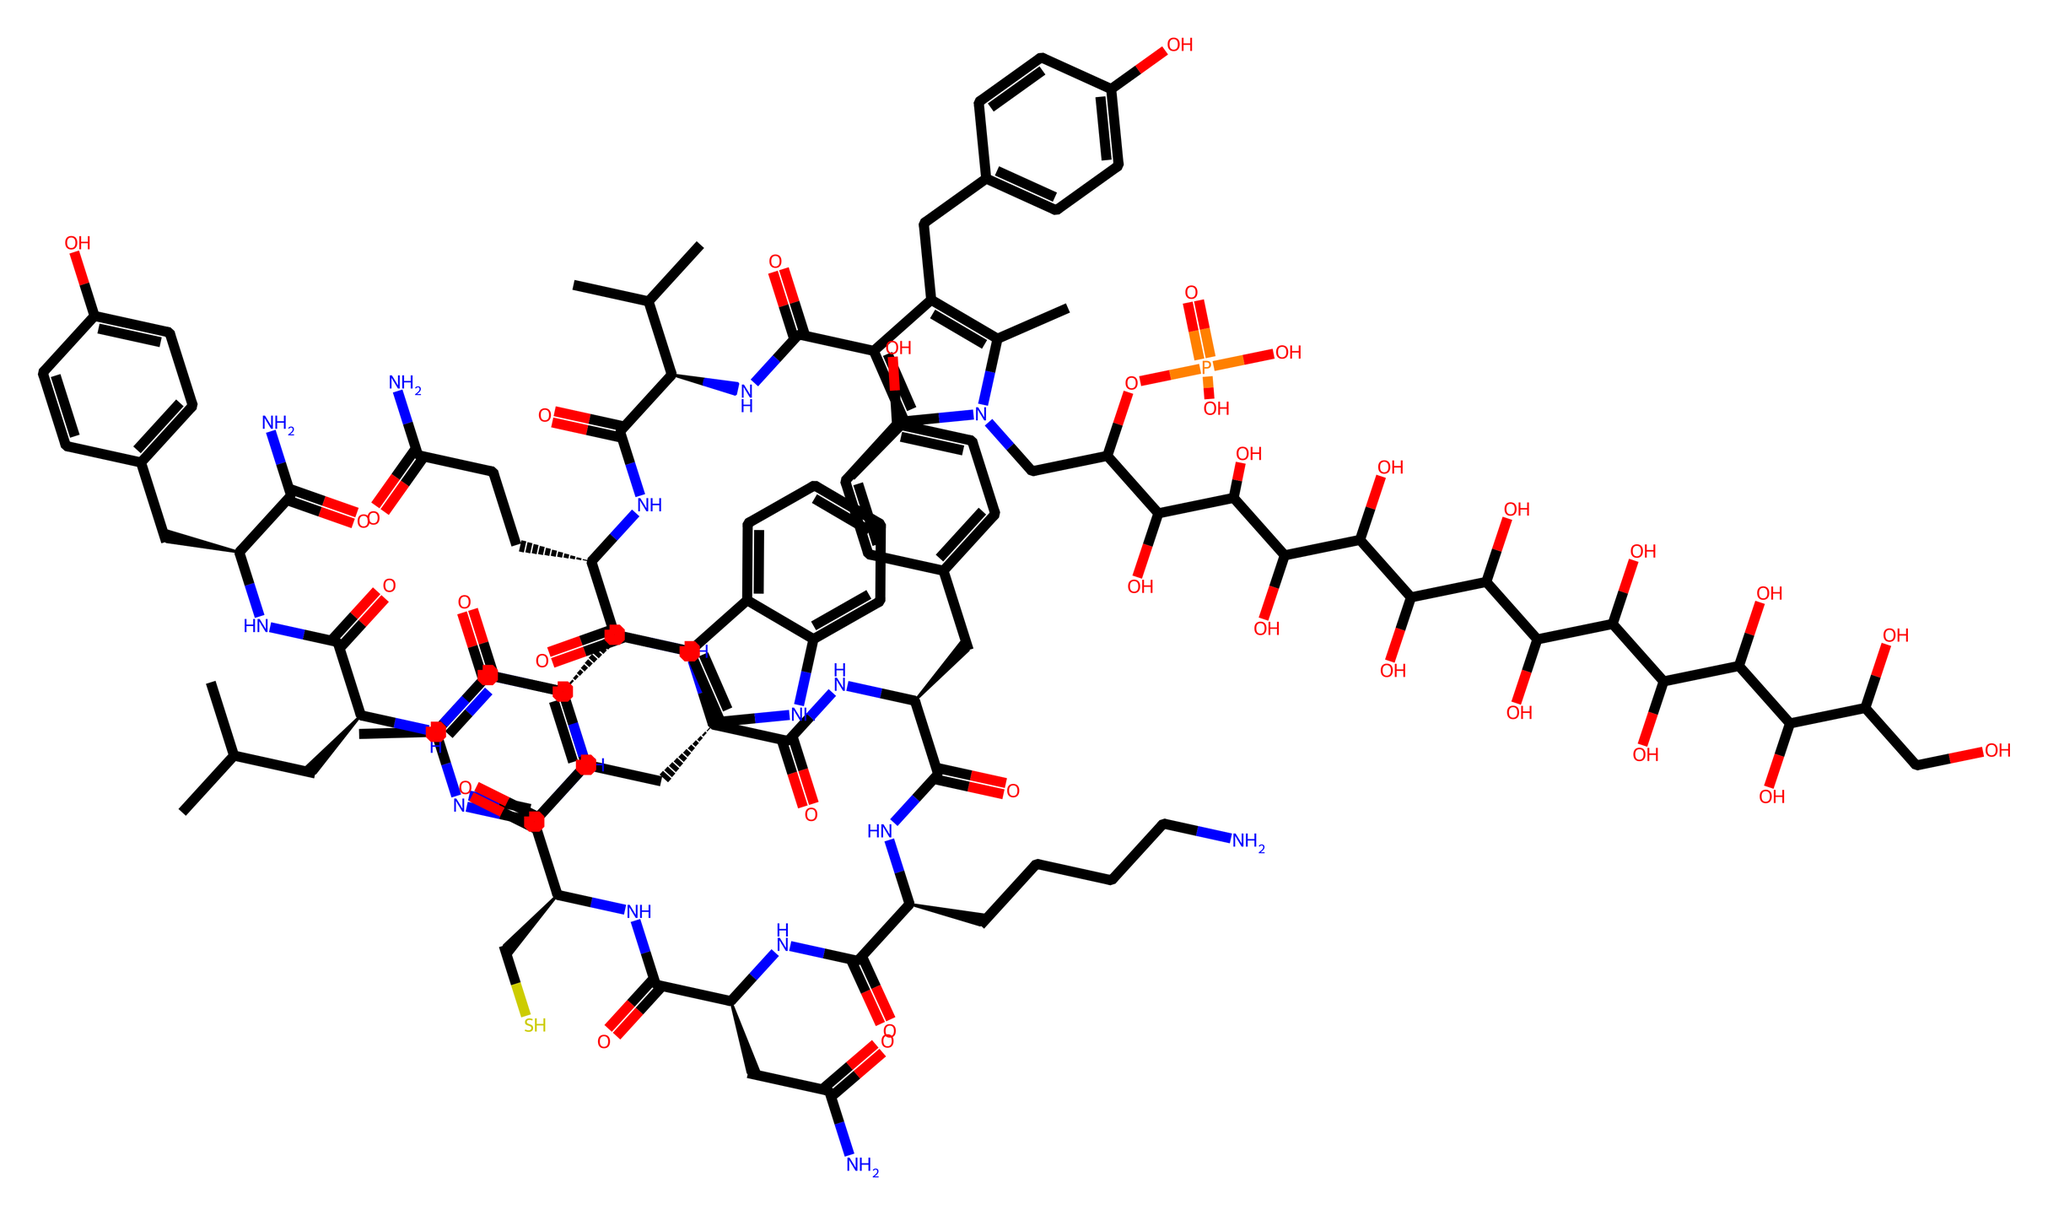What is the molecular formula of vitamin B12? To find the molecular formula, count the number of each type of atom in the SMILES representation. The counts are: Carbon (C): 63, Hydrogen (H): 88, Nitrogen (N): 14, Oxygen (O): 20, Phosphorus (P): 1. Therefore, the molecular formula is C63H88N14O20P.
Answer: C63H88N14O20P How many nitrogen atoms are present in the molecule? By examining the SMILES and counting the 'N' characters, we find there are 14 nitrogen atoms.
Answer: 14 What is the role of vitamin B12 in DNA synthesis? Vitamin B12 functions as a coenzyme in the metabolism of DNA. It assists in the synthesis of nucleotides, which are the building blocks of DNA.
Answer: coenzyme in nucleotide synthesis How many hydroxyl groups (-OH) are in this structure? Examine the SMILES for occurrences of 'O' that are not attached to carbonyl groups or within ring structures. Here, 12 hydroxyl groups can be identified.
Answer: 12 Which part of the molecule contains the cobalt atom central to its function? The central cobalt atom is located within the corrin ring structure of vitamin B12, which can be indicated by the cyano or methyl groups attached directly to it.
Answer: corrin ring How is the phosphorus atom connected in the structure? The phosphorus atom is involved in a phosphate group (-OP(=O)(O)O), which is indicated within the SMILES as 'P(=O)(O)O.' This defines its linkage within a phosphoric acid structure.
Answer: phosphate group What type of compound does vitamin B12 belong to? Based on its structure, vitamin B12 is classified as a cobalamin, due to its cobalt-containing corrin structure essential for its biological functions.
Answer: cobalamin 